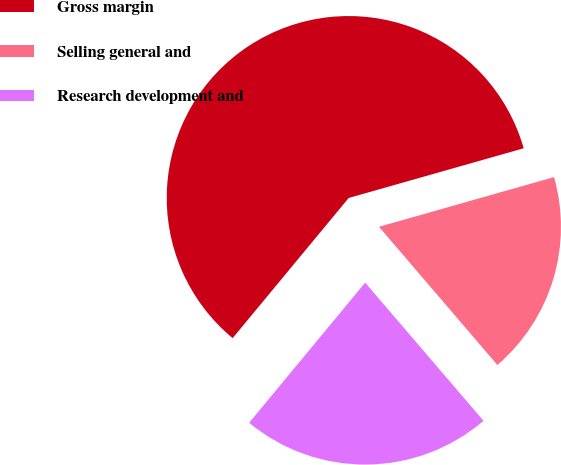<chart> <loc_0><loc_0><loc_500><loc_500><pie_chart><fcel>Gross margin<fcel>Selling general and<fcel>Research development and<nl><fcel>59.59%<fcel>18.13%<fcel>22.28%<nl></chart> 